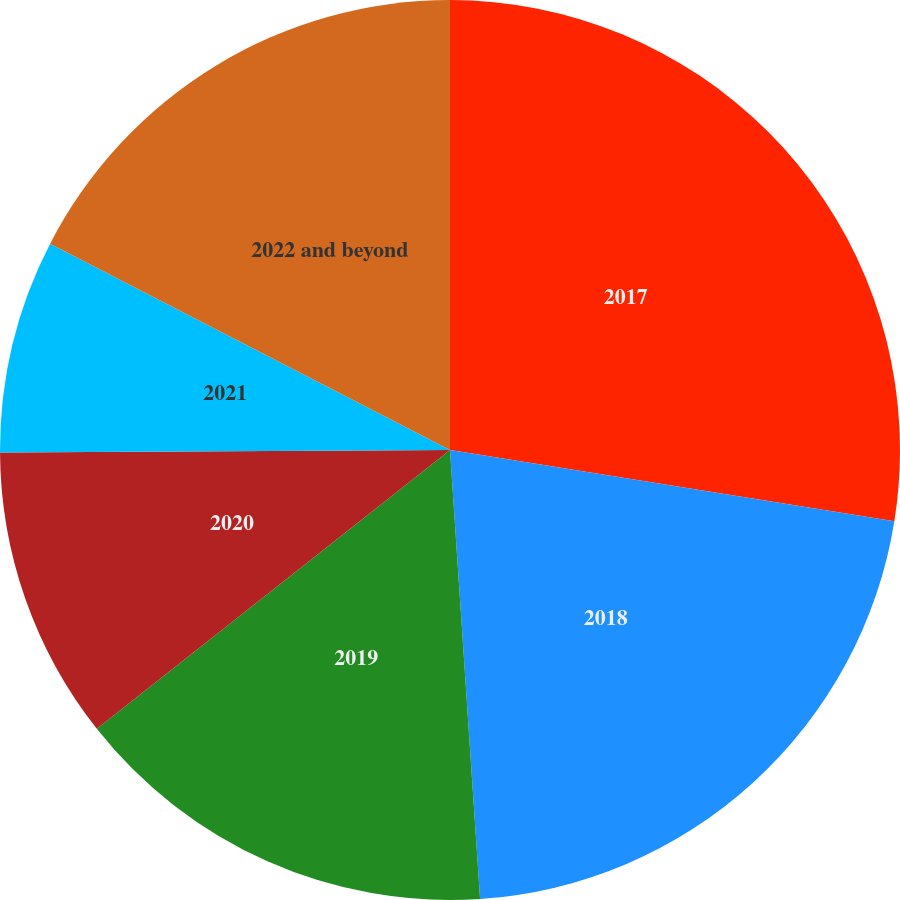Convert chart to OTSL. <chart><loc_0><loc_0><loc_500><loc_500><pie_chart><fcel>2017<fcel>2018<fcel>2019<fcel>2020<fcel>2021<fcel>2022 and beyond<nl><fcel>27.53%<fcel>21.41%<fcel>15.43%<fcel>10.55%<fcel>7.67%<fcel>17.42%<nl></chart> 